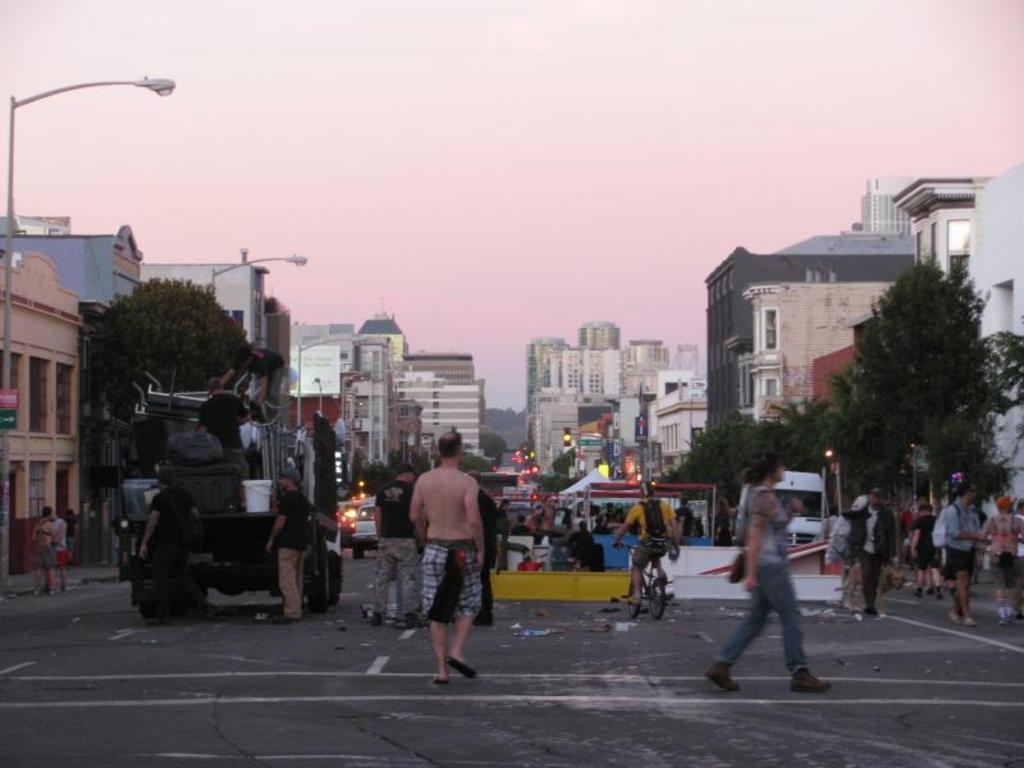In one or two sentences, can you explain what this image depicts? This picture consists of a road, on which I can see vehicles and persons and persons visible on bi-cycle and there are few persons visible on truck, on the right side I can see buildings , trees, persons,at the top there is the sky, on the left side I can see buildings, street light poles , tree and there is a tent visible in the middle under the tent I can see persons. 